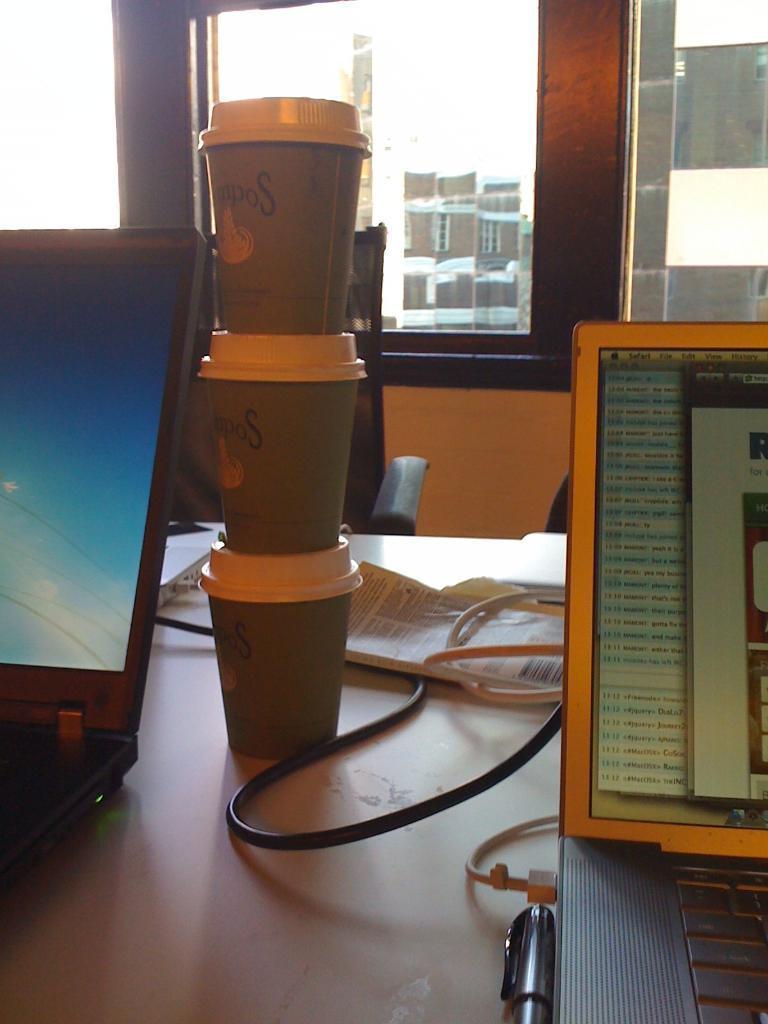Please provide a concise description of this image. In the foreground of the picture there is a table, on the table there are cups, laptops, book, cable, pen. In the center of the picture there is a chair. In the background there are windows, outside the window there are buildings. 